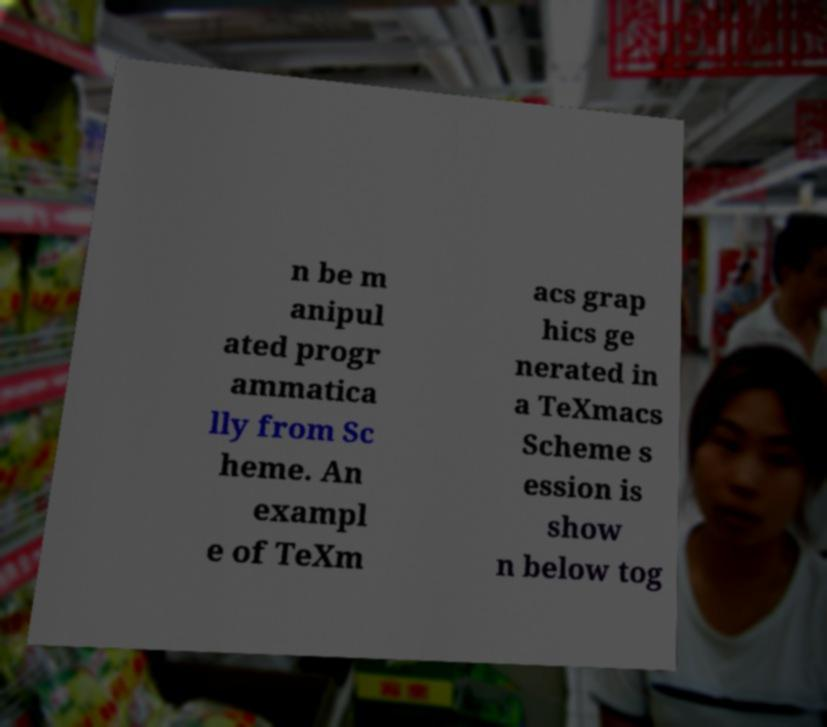Can you accurately transcribe the text from the provided image for me? n be m anipul ated progr ammatica lly from Sc heme. An exampl e of TeXm acs grap hics ge nerated in a TeXmacs Scheme s ession is show n below tog 